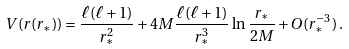Convert formula to latex. <formula><loc_0><loc_0><loc_500><loc_500>V ( r ( r _ { * } ) ) = \frac { \ell ( \ell + 1 ) } { r _ { * } ^ { 2 } } + 4 M \frac { \ell ( \ell + 1 ) } { r _ { * } ^ { 3 } } \, \ln \frac { r _ { * } } { 2 M } + O ( r _ { * } ^ { - 3 } ) \, .</formula> 